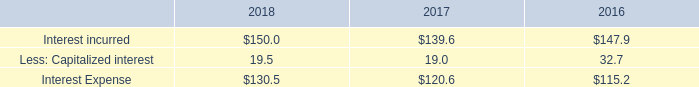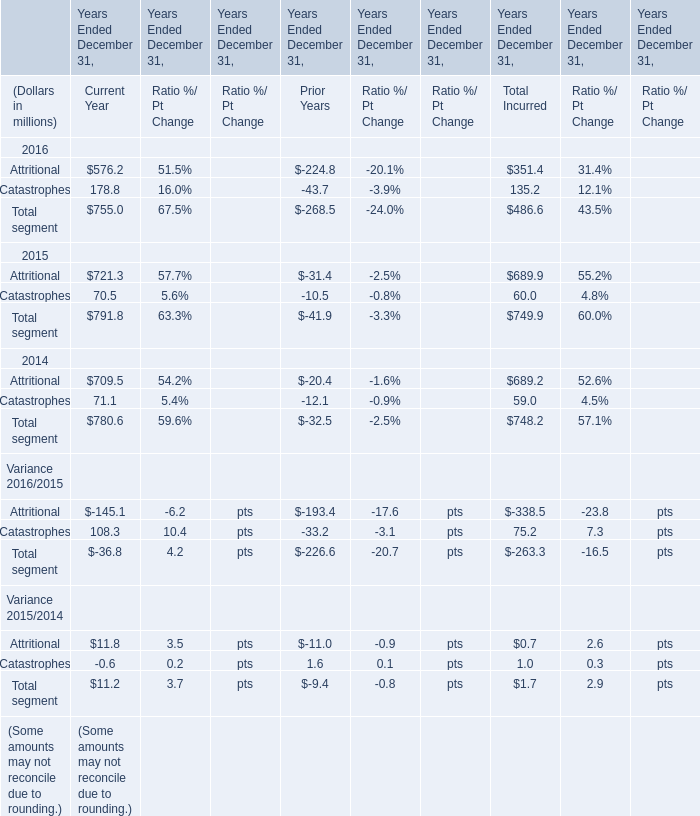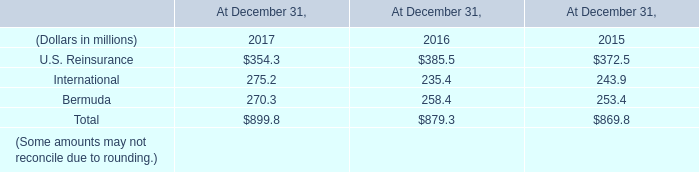In the year with largest amount of Catastrophes of Current Year in Table 1, what's the sum of elements in Table 2? (in million) 
Computations: ((385.5 + 235.4) + 258.4)
Answer: 879.3. 